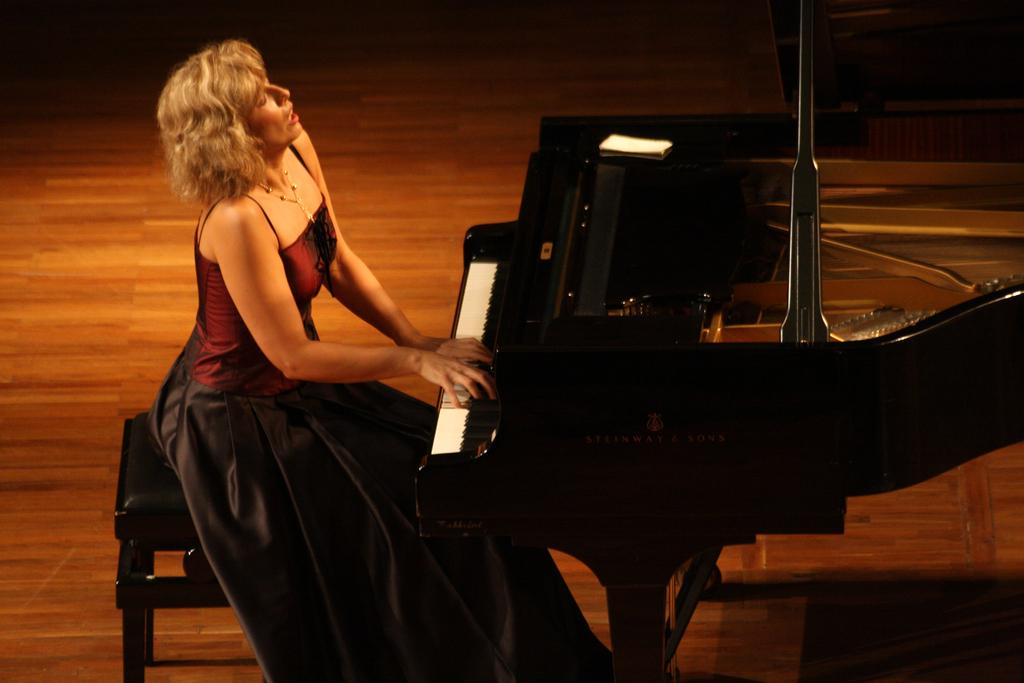Who is the main subject in the image? There is a woman in the image. What is the woman doing in the image? The woman is sitting on a chair and playing a piano. What part of the piano is visible in the image? The piano has a keyboard. What type of fruit is being used to play the piano in the image? There is no fruit present in the image, and the piano is being played with the woman's hands on the keyboard. 